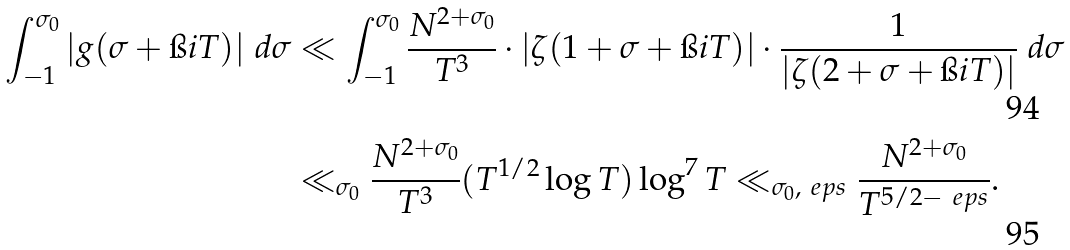Convert formula to latex. <formula><loc_0><loc_0><loc_500><loc_500>\int _ { - 1 } ^ { \sigma _ { 0 } } | g ( \sigma + \i i T ) | \ d \sigma & \ll \int _ { - 1 } ^ { \sigma _ { 0 } } \frac { N ^ { 2 + \sigma _ { 0 } } } { T ^ { 3 } } \cdot | \zeta ( 1 + \sigma + \i i T ) | \cdot \frac { 1 } { | \zeta ( 2 + \sigma + \i i T ) | } \ d \sigma \\ & \ll _ { \sigma _ { 0 } } \frac { N ^ { 2 + \sigma _ { 0 } } } { T ^ { 3 } } ( T ^ { 1 / 2 } \log T ) \log ^ { 7 } T \ll _ { \sigma _ { 0 } , \ e p s } \frac { N ^ { 2 + \sigma _ { 0 } } } { T ^ { 5 / 2 - \ e p s } } .</formula> 